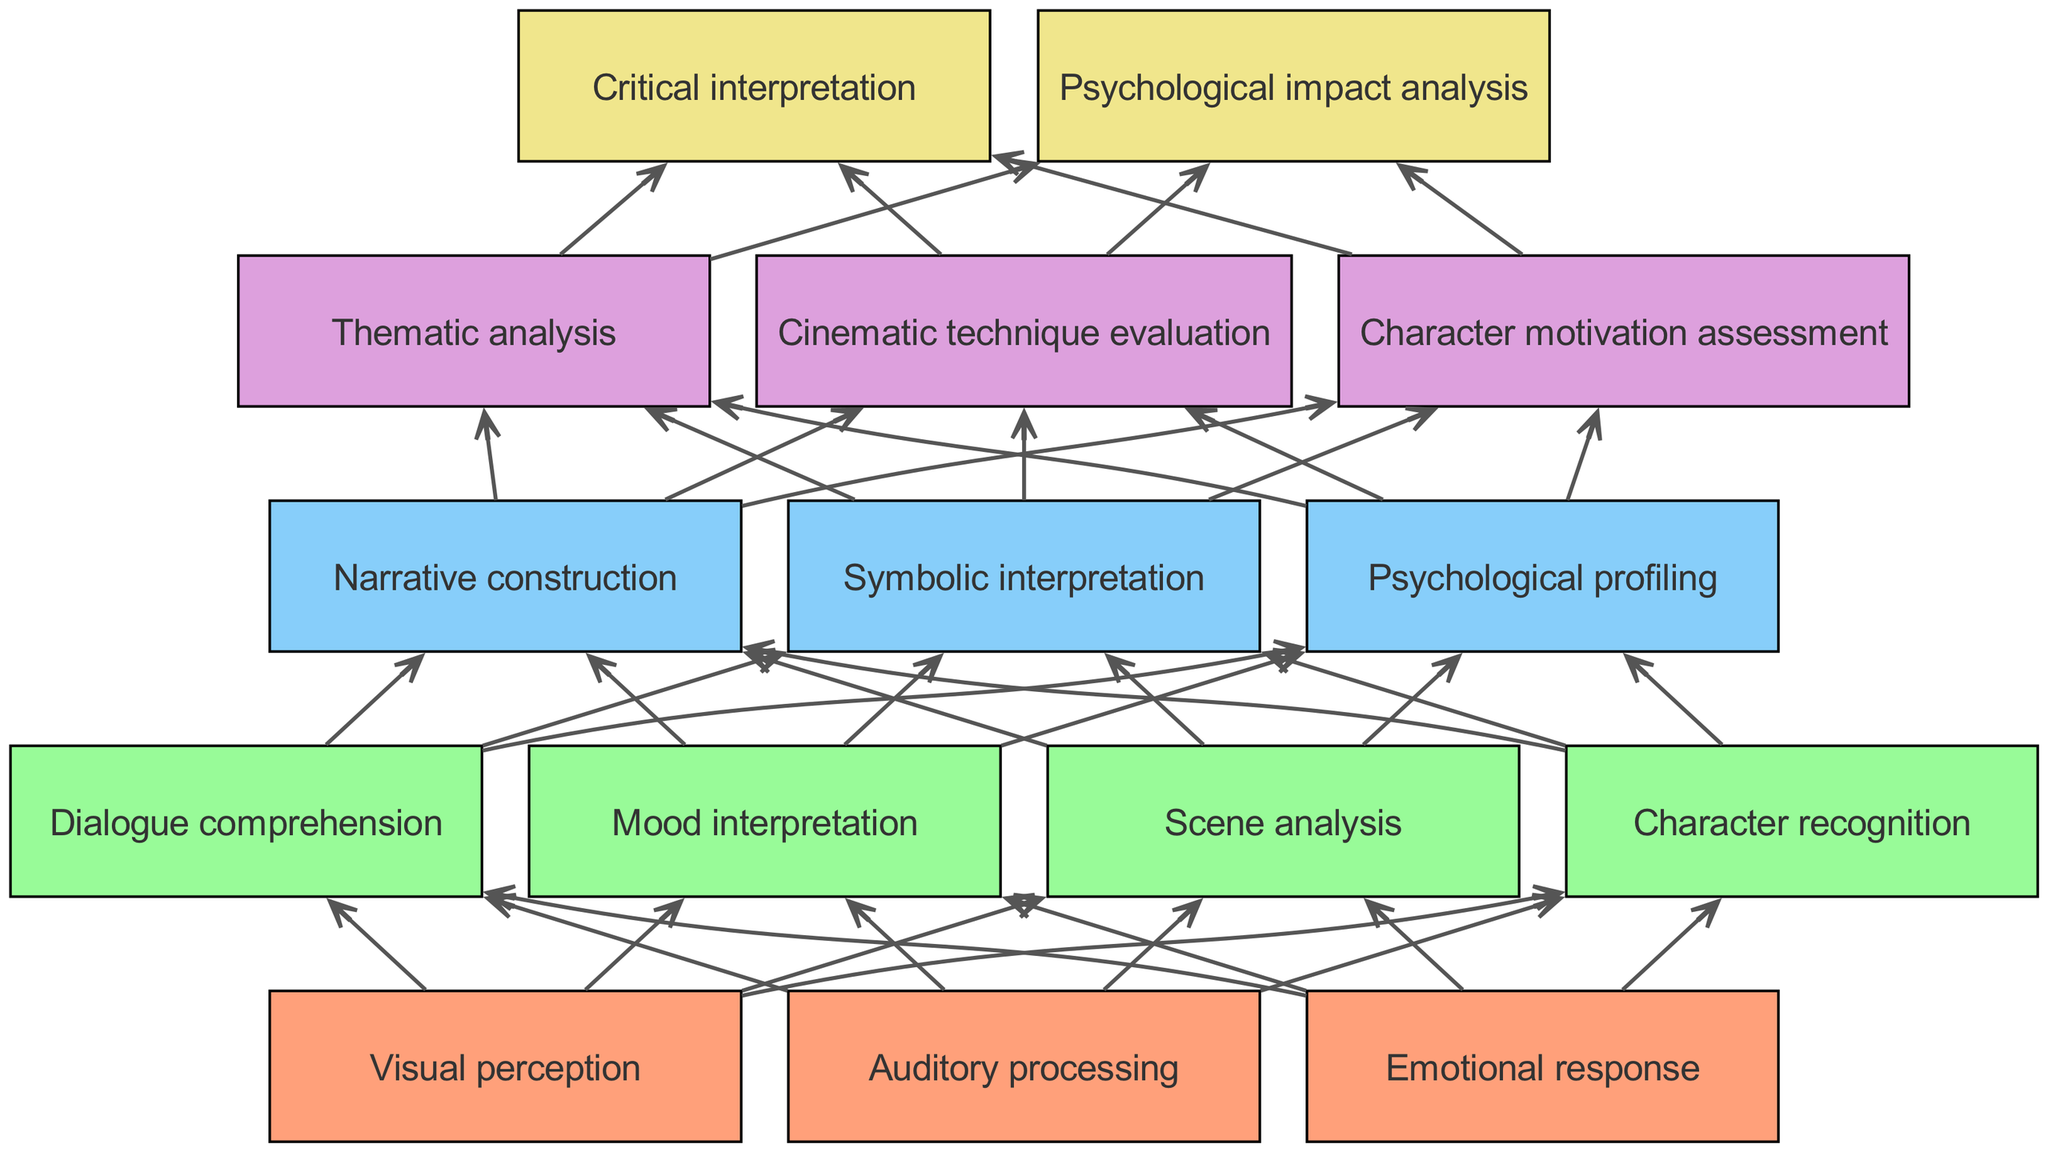What are the three elements at level 1? The elements in level 1 are visually identified as "Visual perception", "Auditory processing", and "Emotional response", representing the first stage of cognitive processes in film analysis.
Answer: Visual perception, Auditory processing, Emotional response How many items are there in level 3? By counting the items under level 3, it is determined that there are three items: "Narrative construction", "Symbolic interpretation", and "Psychological profiling".
Answer: 3 Which item connects "Dialogue comprehension" to "Narrative construction"? The connection flows from "Dialogue comprehension" in level 2 to "Narrative construction" in level 3, indicating a sequential cognitive process in analyzing film dialogue as it contributes to building narrative.
Answer: Narrative construction What is the last item in level 5? The item listed last in level 5 is "Psychological impact analysis", which represents one of the higher-order cognitive processes in the analysis of film.
Answer: Psychological impact analysis How many edges connect from level 2 to level 3? Analyzing the edges shows that there are a total of four connections from the four items in level 2: "Scene analysis", "Character recognition", "Dialogue comprehension", and "Mood interpretation", leading into the three items in level 3, effectively creating multiple pathways.
Answer: 4 Which item at level 4 relates to character assessment? The item in level 4 that specifically relates to character assessment is "Character motivation assessment", indicating an analysis that delves into understanding characters' intentions and emotional drivers.
Answer: Character motivation assessment What type of analysis is at the top of level 5? At the top of level 5, the type of analysis represented as the first item is "Critical interpretation", highlighting a significant evaluative phase in the cognitive processing pathway.
Answer: Critical interpretation Which layer introduces psychological profiling? Psychological profiling is introduced in level 3, marking a deeper analytical process that incorporates psychological theories and insights into character behaviors observed in films.
Answer: Level 3 How many levels are there in the flow chart? Upon reviewing the provided structure, it is identified that there are five distinct levels, ranging from sensory perception to critical interpretation.
Answer: 5 